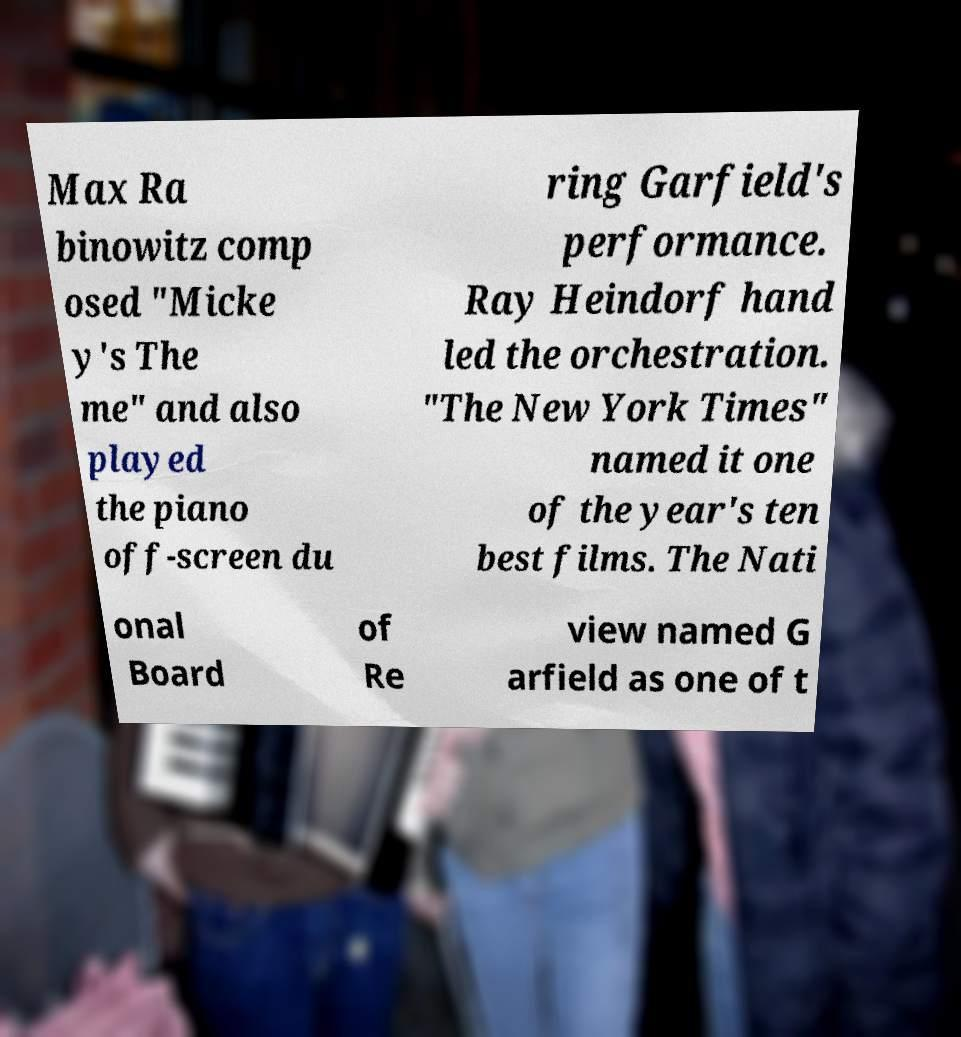There's text embedded in this image that I need extracted. Can you transcribe it verbatim? Max Ra binowitz comp osed "Micke y's The me" and also played the piano off-screen du ring Garfield's performance. Ray Heindorf hand led the orchestration. "The New York Times" named it one of the year's ten best films. The Nati onal Board of Re view named G arfield as one of t 